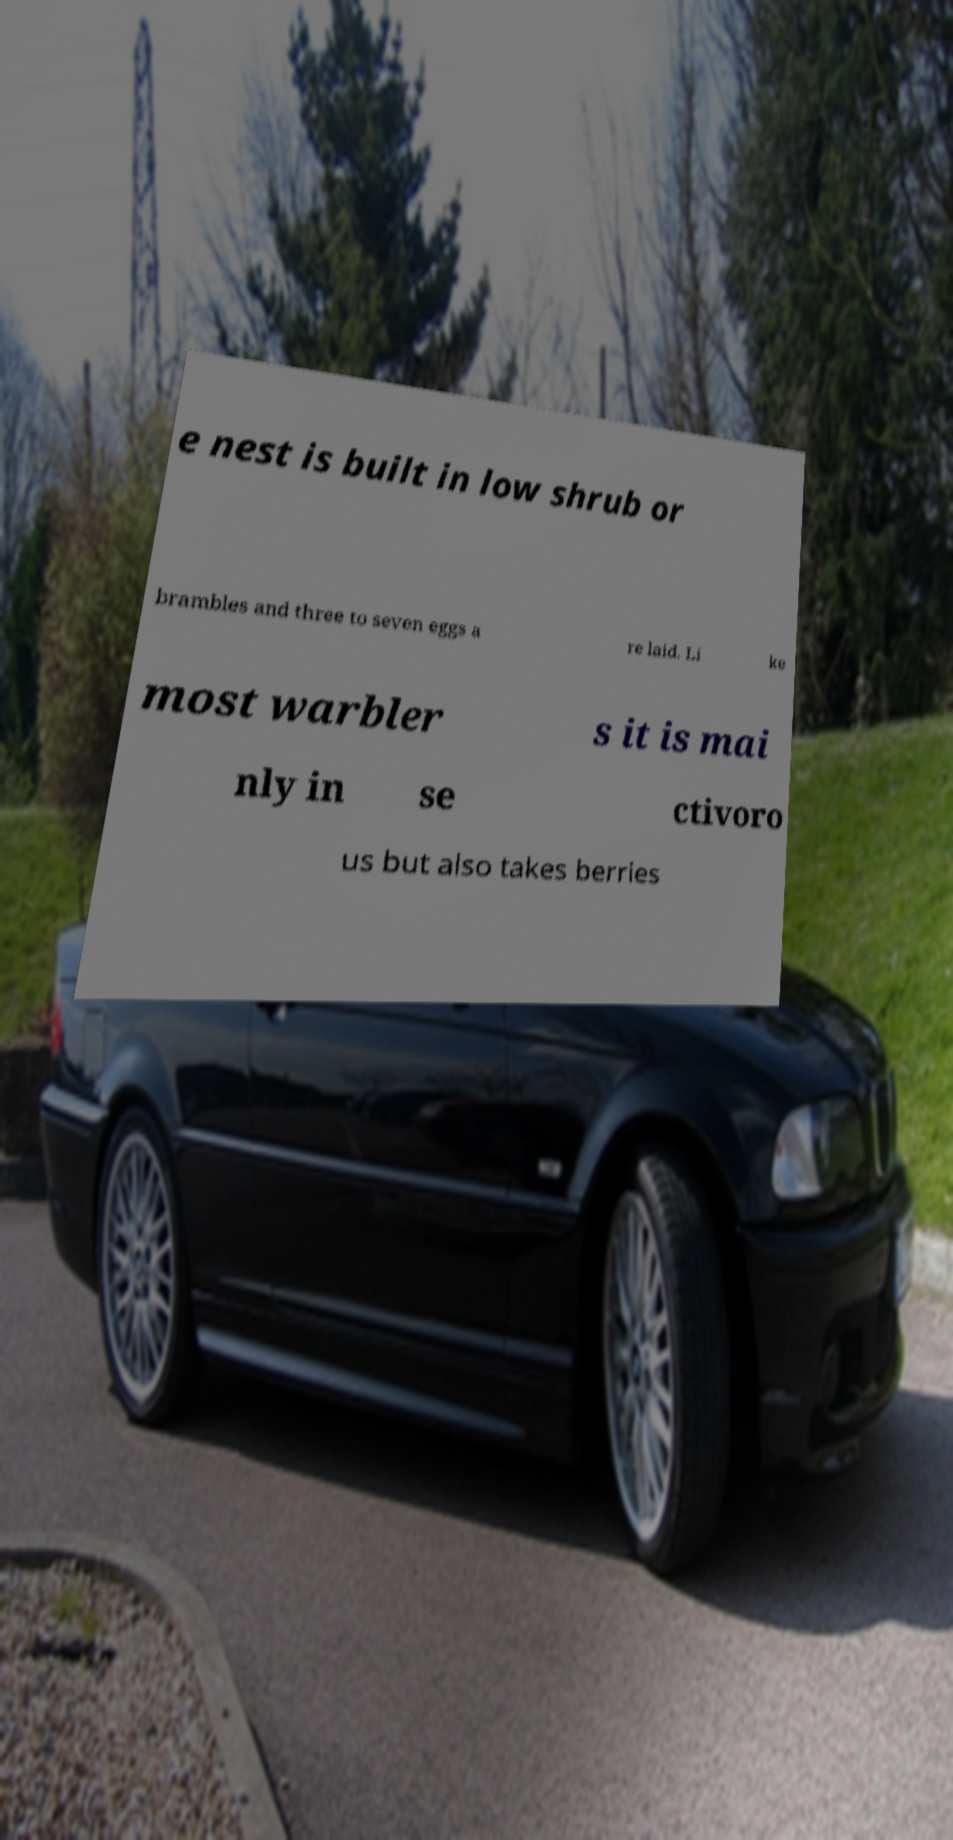For documentation purposes, I need the text within this image transcribed. Could you provide that? e nest is built in low shrub or brambles and three to seven eggs a re laid. Li ke most warbler s it is mai nly in se ctivoro us but also takes berries 